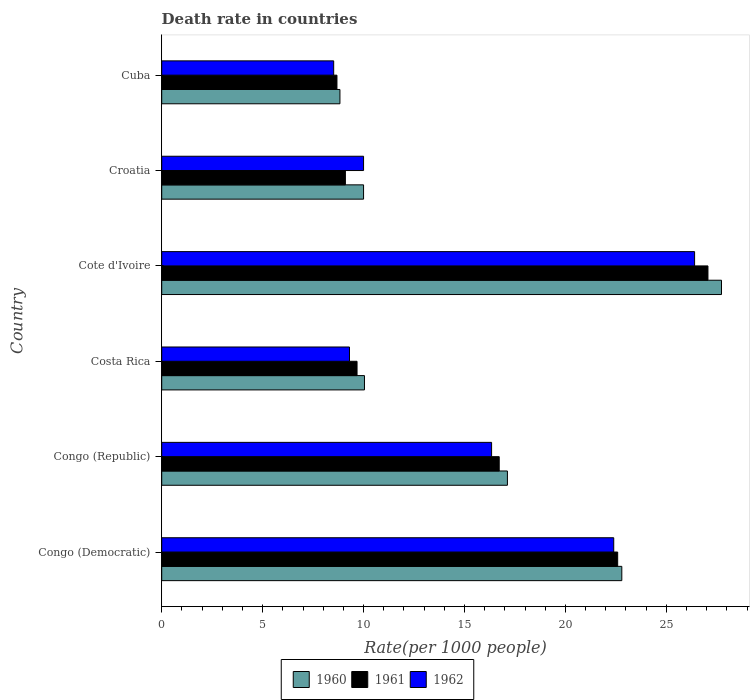How many groups of bars are there?
Offer a terse response. 6. Are the number of bars per tick equal to the number of legend labels?
Make the answer very short. Yes. Are the number of bars on each tick of the Y-axis equal?
Keep it short and to the point. Yes. How many bars are there on the 6th tick from the bottom?
Keep it short and to the point. 3. What is the label of the 2nd group of bars from the top?
Provide a short and direct response. Croatia. In how many cases, is the number of bars for a given country not equal to the number of legend labels?
Provide a succinct answer. 0. What is the death rate in 1960 in Congo (Republic)?
Offer a very short reply. 17.13. Across all countries, what is the maximum death rate in 1962?
Your answer should be very brief. 26.4. Across all countries, what is the minimum death rate in 1961?
Keep it short and to the point. 8.68. In which country was the death rate in 1960 maximum?
Make the answer very short. Cote d'Ivoire. In which country was the death rate in 1962 minimum?
Your answer should be very brief. Cuba. What is the total death rate in 1962 in the graph?
Ensure brevity in your answer.  92.96. What is the difference between the death rate in 1961 in Cote d'Ivoire and that in Croatia?
Give a very brief answer. 17.96. What is the difference between the death rate in 1961 in Cuba and the death rate in 1960 in Cote d'Ivoire?
Keep it short and to the point. -19.05. What is the average death rate in 1960 per country?
Your response must be concise. 16.09. What is the difference between the death rate in 1960 and death rate in 1962 in Cote d'Ivoire?
Provide a short and direct response. 1.33. In how many countries, is the death rate in 1961 greater than 23 ?
Your response must be concise. 1. What is the ratio of the death rate in 1962 in Congo (Democratic) to that in Congo (Republic)?
Keep it short and to the point. 1.37. Is the difference between the death rate in 1960 in Cote d'Ivoire and Cuba greater than the difference between the death rate in 1962 in Cote d'Ivoire and Cuba?
Offer a very short reply. Yes. What is the difference between the highest and the second highest death rate in 1960?
Make the answer very short. 4.94. What is the difference between the highest and the lowest death rate in 1962?
Ensure brevity in your answer.  17.88. In how many countries, is the death rate in 1961 greater than the average death rate in 1961 taken over all countries?
Provide a short and direct response. 3. Is the sum of the death rate in 1961 in Congo (Democratic) and Costa Rica greater than the maximum death rate in 1960 across all countries?
Offer a terse response. Yes. What does the 1st bar from the top in Cote d'Ivoire represents?
Your answer should be very brief. 1962. What does the 1st bar from the bottom in Congo (Republic) represents?
Provide a succinct answer. 1960. How many bars are there?
Give a very brief answer. 18. How many countries are there in the graph?
Offer a very short reply. 6. What is the difference between two consecutive major ticks on the X-axis?
Give a very brief answer. 5. Does the graph contain any zero values?
Offer a very short reply. No. Does the graph contain grids?
Your answer should be very brief. No. Where does the legend appear in the graph?
Provide a short and direct response. Bottom center. What is the title of the graph?
Offer a terse response. Death rate in countries. What is the label or title of the X-axis?
Make the answer very short. Rate(per 1000 people). What is the label or title of the Y-axis?
Keep it short and to the point. Country. What is the Rate(per 1000 people) of 1960 in Congo (Democratic)?
Provide a short and direct response. 22.79. What is the Rate(per 1000 people) of 1961 in Congo (Democratic)?
Your answer should be compact. 22.59. What is the Rate(per 1000 people) of 1962 in Congo (Democratic)?
Provide a short and direct response. 22.39. What is the Rate(per 1000 people) in 1960 in Congo (Republic)?
Keep it short and to the point. 17.13. What is the Rate(per 1000 people) in 1961 in Congo (Republic)?
Offer a very short reply. 16.72. What is the Rate(per 1000 people) in 1962 in Congo (Republic)?
Give a very brief answer. 16.34. What is the Rate(per 1000 people) in 1960 in Costa Rica?
Make the answer very short. 10.04. What is the Rate(per 1000 people) of 1961 in Costa Rica?
Provide a short and direct response. 9.68. What is the Rate(per 1000 people) of 1962 in Costa Rica?
Keep it short and to the point. 9.3. What is the Rate(per 1000 people) in 1960 in Cote d'Ivoire?
Offer a very short reply. 27.73. What is the Rate(per 1000 people) of 1961 in Cote d'Ivoire?
Your response must be concise. 27.06. What is the Rate(per 1000 people) in 1962 in Cote d'Ivoire?
Offer a terse response. 26.4. What is the Rate(per 1000 people) in 1960 in Croatia?
Provide a short and direct response. 10. What is the Rate(per 1000 people) in 1962 in Croatia?
Offer a terse response. 10. What is the Rate(per 1000 people) of 1960 in Cuba?
Keep it short and to the point. 8.83. What is the Rate(per 1000 people) of 1961 in Cuba?
Make the answer very short. 8.68. What is the Rate(per 1000 people) of 1962 in Cuba?
Keep it short and to the point. 8.52. Across all countries, what is the maximum Rate(per 1000 people) of 1960?
Provide a short and direct response. 27.73. Across all countries, what is the maximum Rate(per 1000 people) of 1961?
Give a very brief answer. 27.06. Across all countries, what is the maximum Rate(per 1000 people) of 1962?
Your answer should be compact. 26.4. Across all countries, what is the minimum Rate(per 1000 people) of 1960?
Offer a terse response. 8.83. Across all countries, what is the minimum Rate(per 1000 people) of 1961?
Ensure brevity in your answer.  8.68. Across all countries, what is the minimum Rate(per 1000 people) of 1962?
Ensure brevity in your answer.  8.52. What is the total Rate(per 1000 people) of 1960 in the graph?
Your answer should be compact. 96.53. What is the total Rate(per 1000 people) of 1961 in the graph?
Keep it short and to the point. 93.83. What is the total Rate(per 1000 people) of 1962 in the graph?
Your response must be concise. 92.96. What is the difference between the Rate(per 1000 people) of 1960 in Congo (Democratic) and that in Congo (Republic)?
Provide a short and direct response. 5.67. What is the difference between the Rate(per 1000 people) in 1961 in Congo (Democratic) and that in Congo (Republic)?
Your answer should be very brief. 5.87. What is the difference between the Rate(per 1000 people) in 1962 in Congo (Democratic) and that in Congo (Republic)?
Keep it short and to the point. 6.05. What is the difference between the Rate(per 1000 people) of 1960 in Congo (Democratic) and that in Costa Rica?
Provide a short and direct response. 12.75. What is the difference between the Rate(per 1000 people) of 1961 in Congo (Democratic) and that in Costa Rica?
Offer a very short reply. 12.91. What is the difference between the Rate(per 1000 people) in 1962 in Congo (Democratic) and that in Costa Rica?
Your response must be concise. 13.09. What is the difference between the Rate(per 1000 people) in 1960 in Congo (Democratic) and that in Cote d'Ivoire?
Your response must be concise. -4.94. What is the difference between the Rate(per 1000 people) in 1961 in Congo (Democratic) and that in Cote d'Ivoire?
Your answer should be compact. -4.47. What is the difference between the Rate(per 1000 people) in 1962 in Congo (Democratic) and that in Cote d'Ivoire?
Your response must be concise. -4.01. What is the difference between the Rate(per 1000 people) in 1960 in Congo (Democratic) and that in Croatia?
Your answer should be very brief. 12.79. What is the difference between the Rate(per 1000 people) in 1961 in Congo (Democratic) and that in Croatia?
Provide a short and direct response. 13.49. What is the difference between the Rate(per 1000 people) in 1962 in Congo (Democratic) and that in Croatia?
Offer a terse response. 12.39. What is the difference between the Rate(per 1000 people) in 1960 in Congo (Democratic) and that in Cuba?
Your response must be concise. 13.96. What is the difference between the Rate(per 1000 people) of 1961 in Congo (Democratic) and that in Cuba?
Keep it short and to the point. 13.91. What is the difference between the Rate(per 1000 people) of 1962 in Congo (Democratic) and that in Cuba?
Offer a terse response. 13.87. What is the difference between the Rate(per 1000 people) of 1960 in Congo (Republic) and that in Costa Rica?
Your answer should be compact. 7.08. What is the difference between the Rate(per 1000 people) in 1961 in Congo (Republic) and that in Costa Rica?
Give a very brief answer. 7.04. What is the difference between the Rate(per 1000 people) of 1962 in Congo (Republic) and that in Costa Rica?
Your response must be concise. 7.04. What is the difference between the Rate(per 1000 people) of 1960 in Congo (Republic) and that in Cote d'Ivoire?
Your response must be concise. -10.61. What is the difference between the Rate(per 1000 people) of 1961 in Congo (Republic) and that in Cote d'Ivoire?
Make the answer very short. -10.34. What is the difference between the Rate(per 1000 people) in 1962 in Congo (Republic) and that in Cote d'Ivoire?
Offer a very short reply. -10.06. What is the difference between the Rate(per 1000 people) in 1960 in Congo (Republic) and that in Croatia?
Offer a very short reply. 7.13. What is the difference between the Rate(per 1000 people) in 1961 in Congo (Republic) and that in Croatia?
Your answer should be very brief. 7.62. What is the difference between the Rate(per 1000 people) in 1962 in Congo (Republic) and that in Croatia?
Ensure brevity in your answer.  6.34. What is the difference between the Rate(per 1000 people) in 1960 in Congo (Republic) and that in Cuba?
Your response must be concise. 8.3. What is the difference between the Rate(per 1000 people) of 1961 in Congo (Republic) and that in Cuba?
Give a very brief answer. 8.04. What is the difference between the Rate(per 1000 people) of 1962 in Congo (Republic) and that in Cuba?
Give a very brief answer. 7.82. What is the difference between the Rate(per 1000 people) in 1960 in Costa Rica and that in Cote d'Ivoire?
Your answer should be compact. -17.69. What is the difference between the Rate(per 1000 people) of 1961 in Costa Rica and that in Cote d'Ivoire?
Make the answer very short. -17.39. What is the difference between the Rate(per 1000 people) of 1962 in Costa Rica and that in Cote d'Ivoire?
Your response must be concise. -17.1. What is the difference between the Rate(per 1000 people) in 1960 in Costa Rica and that in Croatia?
Give a very brief answer. 0.04. What is the difference between the Rate(per 1000 people) in 1961 in Costa Rica and that in Croatia?
Provide a succinct answer. 0.58. What is the difference between the Rate(per 1000 people) in 1962 in Costa Rica and that in Croatia?
Keep it short and to the point. -0.7. What is the difference between the Rate(per 1000 people) in 1960 in Costa Rica and that in Cuba?
Provide a succinct answer. 1.22. What is the difference between the Rate(per 1000 people) in 1961 in Costa Rica and that in Cuba?
Make the answer very short. 0.99. What is the difference between the Rate(per 1000 people) in 1962 in Costa Rica and that in Cuba?
Your answer should be very brief. 0.78. What is the difference between the Rate(per 1000 people) in 1960 in Cote d'Ivoire and that in Croatia?
Your response must be concise. 17.73. What is the difference between the Rate(per 1000 people) of 1961 in Cote d'Ivoire and that in Croatia?
Your response must be concise. 17.96. What is the difference between the Rate(per 1000 people) of 1962 in Cote d'Ivoire and that in Croatia?
Your answer should be very brief. 16.4. What is the difference between the Rate(per 1000 people) of 1960 in Cote d'Ivoire and that in Cuba?
Ensure brevity in your answer.  18.9. What is the difference between the Rate(per 1000 people) in 1961 in Cote d'Ivoire and that in Cuba?
Your answer should be very brief. 18.38. What is the difference between the Rate(per 1000 people) in 1962 in Cote d'Ivoire and that in Cuba?
Make the answer very short. 17.88. What is the difference between the Rate(per 1000 people) of 1960 in Croatia and that in Cuba?
Ensure brevity in your answer.  1.17. What is the difference between the Rate(per 1000 people) in 1961 in Croatia and that in Cuba?
Offer a terse response. 0.42. What is the difference between the Rate(per 1000 people) of 1962 in Croatia and that in Cuba?
Your response must be concise. 1.48. What is the difference between the Rate(per 1000 people) in 1960 in Congo (Democratic) and the Rate(per 1000 people) in 1961 in Congo (Republic)?
Your answer should be compact. 6.07. What is the difference between the Rate(per 1000 people) in 1960 in Congo (Democratic) and the Rate(per 1000 people) in 1962 in Congo (Republic)?
Make the answer very short. 6.45. What is the difference between the Rate(per 1000 people) of 1961 in Congo (Democratic) and the Rate(per 1000 people) of 1962 in Congo (Republic)?
Your response must be concise. 6.25. What is the difference between the Rate(per 1000 people) in 1960 in Congo (Democratic) and the Rate(per 1000 people) in 1961 in Costa Rica?
Make the answer very short. 13.12. What is the difference between the Rate(per 1000 people) of 1960 in Congo (Democratic) and the Rate(per 1000 people) of 1962 in Costa Rica?
Provide a succinct answer. 13.49. What is the difference between the Rate(per 1000 people) in 1961 in Congo (Democratic) and the Rate(per 1000 people) in 1962 in Costa Rica?
Provide a succinct answer. 13.29. What is the difference between the Rate(per 1000 people) in 1960 in Congo (Democratic) and the Rate(per 1000 people) in 1961 in Cote d'Ivoire?
Ensure brevity in your answer.  -4.27. What is the difference between the Rate(per 1000 people) of 1960 in Congo (Democratic) and the Rate(per 1000 people) of 1962 in Cote d'Ivoire?
Keep it short and to the point. -3.61. What is the difference between the Rate(per 1000 people) in 1961 in Congo (Democratic) and the Rate(per 1000 people) in 1962 in Cote d'Ivoire?
Give a very brief answer. -3.81. What is the difference between the Rate(per 1000 people) of 1960 in Congo (Democratic) and the Rate(per 1000 people) of 1961 in Croatia?
Provide a short and direct response. 13.69. What is the difference between the Rate(per 1000 people) in 1960 in Congo (Democratic) and the Rate(per 1000 people) in 1962 in Croatia?
Offer a very short reply. 12.79. What is the difference between the Rate(per 1000 people) of 1961 in Congo (Democratic) and the Rate(per 1000 people) of 1962 in Croatia?
Provide a succinct answer. 12.59. What is the difference between the Rate(per 1000 people) in 1960 in Congo (Democratic) and the Rate(per 1000 people) in 1961 in Cuba?
Keep it short and to the point. 14.11. What is the difference between the Rate(per 1000 people) of 1960 in Congo (Democratic) and the Rate(per 1000 people) of 1962 in Cuba?
Keep it short and to the point. 14.27. What is the difference between the Rate(per 1000 people) of 1961 in Congo (Democratic) and the Rate(per 1000 people) of 1962 in Cuba?
Your response must be concise. 14.07. What is the difference between the Rate(per 1000 people) in 1960 in Congo (Republic) and the Rate(per 1000 people) in 1961 in Costa Rica?
Offer a terse response. 7.45. What is the difference between the Rate(per 1000 people) of 1960 in Congo (Republic) and the Rate(per 1000 people) of 1962 in Costa Rica?
Your answer should be compact. 7.82. What is the difference between the Rate(per 1000 people) in 1961 in Congo (Republic) and the Rate(per 1000 people) in 1962 in Costa Rica?
Keep it short and to the point. 7.42. What is the difference between the Rate(per 1000 people) in 1960 in Congo (Republic) and the Rate(per 1000 people) in 1961 in Cote d'Ivoire?
Your response must be concise. -9.94. What is the difference between the Rate(per 1000 people) of 1960 in Congo (Republic) and the Rate(per 1000 people) of 1962 in Cote d'Ivoire?
Your answer should be very brief. -9.27. What is the difference between the Rate(per 1000 people) in 1961 in Congo (Republic) and the Rate(per 1000 people) in 1962 in Cote d'Ivoire?
Make the answer very short. -9.68. What is the difference between the Rate(per 1000 people) of 1960 in Congo (Republic) and the Rate(per 1000 people) of 1961 in Croatia?
Your answer should be very brief. 8.03. What is the difference between the Rate(per 1000 people) in 1960 in Congo (Republic) and the Rate(per 1000 people) in 1962 in Croatia?
Provide a short and direct response. 7.13. What is the difference between the Rate(per 1000 people) in 1961 in Congo (Republic) and the Rate(per 1000 people) in 1962 in Croatia?
Ensure brevity in your answer.  6.72. What is the difference between the Rate(per 1000 people) in 1960 in Congo (Republic) and the Rate(per 1000 people) in 1961 in Cuba?
Offer a terse response. 8.45. What is the difference between the Rate(per 1000 people) of 1960 in Congo (Republic) and the Rate(per 1000 people) of 1962 in Cuba?
Offer a terse response. 8.61. What is the difference between the Rate(per 1000 people) of 1961 in Congo (Republic) and the Rate(per 1000 people) of 1962 in Cuba?
Provide a short and direct response. 8.2. What is the difference between the Rate(per 1000 people) of 1960 in Costa Rica and the Rate(per 1000 people) of 1961 in Cote d'Ivoire?
Your response must be concise. -17.02. What is the difference between the Rate(per 1000 people) in 1960 in Costa Rica and the Rate(per 1000 people) in 1962 in Cote d'Ivoire?
Offer a very short reply. -16.36. What is the difference between the Rate(per 1000 people) of 1961 in Costa Rica and the Rate(per 1000 people) of 1962 in Cote d'Ivoire?
Offer a very short reply. -16.72. What is the difference between the Rate(per 1000 people) of 1960 in Costa Rica and the Rate(per 1000 people) of 1961 in Croatia?
Keep it short and to the point. 0.94. What is the difference between the Rate(per 1000 people) of 1960 in Costa Rica and the Rate(per 1000 people) of 1962 in Croatia?
Your answer should be very brief. 0.04. What is the difference between the Rate(per 1000 people) in 1961 in Costa Rica and the Rate(per 1000 people) in 1962 in Croatia?
Your answer should be very brief. -0.32. What is the difference between the Rate(per 1000 people) in 1960 in Costa Rica and the Rate(per 1000 people) in 1961 in Cuba?
Offer a terse response. 1.36. What is the difference between the Rate(per 1000 people) of 1960 in Costa Rica and the Rate(per 1000 people) of 1962 in Cuba?
Ensure brevity in your answer.  1.52. What is the difference between the Rate(per 1000 people) in 1961 in Costa Rica and the Rate(per 1000 people) in 1962 in Cuba?
Offer a very short reply. 1.16. What is the difference between the Rate(per 1000 people) in 1960 in Cote d'Ivoire and the Rate(per 1000 people) in 1961 in Croatia?
Keep it short and to the point. 18.63. What is the difference between the Rate(per 1000 people) of 1960 in Cote d'Ivoire and the Rate(per 1000 people) of 1962 in Croatia?
Provide a succinct answer. 17.73. What is the difference between the Rate(per 1000 people) of 1961 in Cote d'Ivoire and the Rate(per 1000 people) of 1962 in Croatia?
Give a very brief answer. 17.06. What is the difference between the Rate(per 1000 people) in 1960 in Cote d'Ivoire and the Rate(per 1000 people) in 1961 in Cuba?
Keep it short and to the point. 19.05. What is the difference between the Rate(per 1000 people) in 1960 in Cote d'Ivoire and the Rate(per 1000 people) in 1962 in Cuba?
Your answer should be very brief. 19.21. What is the difference between the Rate(per 1000 people) of 1961 in Cote d'Ivoire and the Rate(per 1000 people) of 1962 in Cuba?
Ensure brevity in your answer.  18.54. What is the difference between the Rate(per 1000 people) of 1960 in Croatia and the Rate(per 1000 people) of 1961 in Cuba?
Provide a short and direct response. 1.32. What is the difference between the Rate(per 1000 people) of 1960 in Croatia and the Rate(per 1000 people) of 1962 in Cuba?
Ensure brevity in your answer.  1.48. What is the difference between the Rate(per 1000 people) in 1961 in Croatia and the Rate(per 1000 people) in 1962 in Cuba?
Keep it short and to the point. 0.58. What is the average Rate(per 1000 people) of 1960 per country?
Provide a succinct answer. 16.09. What is the average Rate(per 1000 people) of 1961 per country?
Provide a short and direct response. 15.64. What is the average Rate(per 1000 people) in 1962 per country?
Your answer should be compact. 15.49. What is the difference between the Rate(per 1000 people) in 1960 and Rate(per 1000 people) in 1961 in Congo (Democratic)?
Your response must be concise. 0.2. What is the difference between the Rate(per 1000 people) in 1960 and Rate(per 1000 people) in 1962 in Congo (Democratic)?
Offer a terse response. 0.4. What is the difference between the Rate(per 1000 people) of 1961 and Rate(per 1000 people) of 1962 in Congo (Democratic)?
Provide a short and direct response. 0.2. What is the difference between the Rate(per 1000 people) of 1960 and Rate(per 1000 people) of 1961 in Congo (Republic)?
Offer a terse response. 0.41. What is the difference between the Rate(per 1000 people) of 1960 and Rate(per 1000 people) of 1962 in Congo (Republic)?
Your response must be concise. 0.78. What is the difference between the Rate(per 1000 people) in 1961 and Rate(per 1000 people) in 1962 in Congo (Republic)?
Your answer should be very brief. 0.38. What is the difference between the Rate(per 1000 people) in 1960 and Rate(per 1000 people) in 1961 in Costa Rica?
Provide a succinct answer. 0.37. What is the difference between the Rate(per 1000 people) of 1960 and Rate(per 1000 people) of 1962 in Costa Rica?
Offer a terse response. 0.74. What is the difference between the Rate(per 1000 people) in 1961 and Rate(per 1000 people) in 1962 in Costa Rica?
Your answer should be compact. 0.37. What is the difference between the Rate(per 1000 people) of 1960 and Rate(per 1000 people) of 1961 in Cote d'Ivoire?
Offer a terse response. 0.67. What is the difference between the Rate(per 1000 people) in 1960 and Rate(per 1000 people) in 1962 in Cote d'Ivoire?
Your answer should be very brief. 1.33. What is the difference between the Rate(per 1000 people) of 1961 and Rate(per 1000 people) of 1962 in Cote d'Ivoire?
Your answer should be compact. 0.66. What is the difference between the Rate(per 1000 people) in 1960 and Rate(per 1000 people) in 1961 in Cuba?
Your answer should be compact. 0.15. What is the difference between the Rate(per 1000 people) of 1960 and Rate(per 1000 people) of 1962 in Cuba?
Provide a succinct answer. 0.31. What is the difference between the Rate(per 1000 people) of 1961 and Rate(per 1000 people) of 1962 in Cuba?
Make the answer very short. 0.16. What is the ratio of the Rate(per 1000 people) of 1960 in Congo (Democratic) to that in Congo (Republic)?
Offer a terse response. 1.33. What is the ratio of the Rate(per 1000 people) in 1961 in Congo (Democratic) to that in Congo (Republic)?
Ensure brevity in your answer.  1.35. What is the ratio of the Rate(per 1000 people) in 1962 in Congo (Democratic) to that in Congo (Republic)?
Offer a terse response. 1.37. What is the ratio of the Rate(per 1000 people) of 1960 in Congo (Democratic) to that in Costa Rica?
Keep it short and to the point. 2.27. What is the ratio of the Rate(per 1000 people) in 1961 in Congo (Democratic) to that in Costa Rica?
Your answer should be very brief. 2.33. What is the ratio of the Rate(per 1000 people) of 1962 in Congo (Democratic) to that in Costa Rica?
Make the answer very short. 2.41. What is the ratio of the Rate(per 1000 people) of 1960 in Congo (Democratic) to that in Cote d'Ivoire?
Offer a very short reply. 0.82. What is the ratio of the Rate(per 1000 people) of 1961 in Congo (Democratic) to that in Cote d'Ivoire?
Keep it short and to the point. 0.83. What is the ratio of the Rate(per 1000 people) in 1962 in Congo (Democratic) to that in Cote d'Ivoire?
Your answer should be very brief. 0.85. What is the ratio of the Rate(per 1000 people) of 1960 in Congo (Democratic) to that in Croatia?
Provide a short and direct response. 2.28. What is the ratio of the Rate(per 1000 people) in 1961 in Congo (Democratic) to that in Croatia?
Make the answer very short. 2.48. What is the ratio of the Rate(per 1000 people) of 1962 in Congo (Democratic) to that in Croatia?
Make the answer very short. 2.24. What is the ratio of the Rate(per 1000 people) of 1960 in Congo (Democratic) to that in Cuba?
Your response must be concise. 2.58. What is the ratio of the Rate(per 1000 people) of 1961 in Congo (Democratic) to that in Cuba?
Make the answer very short. 2.6. What is the ratio of the Rate(per 1000 people) in 1962 in Congo (Democratic) to that in Cuba?
Provide a short and direct response. 2.63. What is the ratio of the Rate(per 1000 people) of 1960 in Congo (Republic) to that in Costa Rica?
Ensure brevity in your answer.  1.71. What is the ratio of the Rate(per 1000 people) in 1961 in Congo (Republic) to that in Costa Rica?
Provide a short and direct response. 1.73. What is the ratio of the Rate(per 1000 people) in 1962 in Congo (Republic) to that in Costa Rica?
Your answer should be compact. 1.76. What is the ratio of the Rate(per 1000 people) of 1960 in Congo (Republic) to that in Cote d'Ivoire?
Provide a succinct answer. 0.62. What is the ratio of the Rate(per 1000 people) in 1961 in Congo (Republic) to that in Cote d'Ivoire?
Provide a succinct answer. 0.62. What is the ratio of the Rate(per 1000 people) in 1962 in Congo (Republic) to that in Cote d'Ivoire?
Provide a short and direct response. 0.62. What is the ratio of the Rate(per 1000 people) of 1960 in Congo (Republic) to that in Croatia?
Ensure brevity in your answer.  1.71. What is the ratio of the Rate(per 1000 people) of 1961 in Congo (Republic) to that in Croatia?
Offer a very short reply. 1.84. What is the ratio of the Rate(per 1000 people) in 1962 in Congo (Republic) to that in Croatia?
Keep it short and to the point. 1.63. What is the ratio of the Rate(per 1000 people) in 1960 in Congo (Republic) to that in Cuba?
Ensure brevity in your answer.  1.94. What is the ratio of the Rate(per 1000 people) in 1961 in Congo (Republic) to that in Cuba?
Your answer should be very brief. 1.93. What is the ratio of the Rate(per 1000 people) of 1962 in Congo (Republic) to that in Cuba?
Keep it short and to the point. 1.92. What is the ratio of the Rate(per 1000 people) of 1960 in Costa Rica to that in Cote d'Ivoire?
Ensure brevity in your answer.  0.36. What is the ratio of the Rate(per 1000 people) of 1961 in Costa Rica to that in Cote d'Ivoire?
Give a very brief answer. 0.36. What is the ratio of the Rate(per 1000 people) of 1962 in Costa Rica to that in Cote d'Ivoire?
Keep it short and to the point. 0.35. What is the ratio of the Rate(per 1000 people) of 1961 in Costa Rica to that in Croatia?
Your response must be concise. 1.06. What is the ratio of the Rate(per 1000 people) of 1962 in Costa Rica to that in Croatia?
Your answer should be very brief. 0.93. What is the ratio of the Rate(per 1000 people) of 1960 in Costa Rica to that in Cuba?
Your answer should be compact. 1.14. What is the ratio of the Rate(per 1000 people) in 1961 in Costa Rica to that in Cuba?
Your answer should be very brief. 1.11. What is the ratio of the Rate(per 1000 people) in 1962 in Costa Rica to that in Cuba?
Offer a very short reply. 1.09. What is the ratio of the Rate(per 1000 people) in 1960 in Cote d'Ivoire to that in Croatia?
Keep it short and to the point. 2.77. What is the ratio of the Rate(per 1000 people) in 1961 in Cote d'Ivoire to that in Croatia?
Offer a terse response. 2.97. What is the ratio of the Rate(per 1000 people) of 1962 in Cote d'Ivoire to that in Croatia?
Provide a succinct answer. 2.64. What is the ratio of the Rate(per 1000 people) in 1960 in Cote d'Ivoire to that in Cuba?
Give a very brief answer. 3.14. What is the ratio of the Rate(per 1000 people) in 1961 in Cote d'Ivoire to that in Cuba?
Make the answer very short. 3.12. What is the ratio of the Rate(per 1000 people) in 1962 in Cote d'Ivoire to that in Cuba?
Provide a short and direct response. 3.1. What is the ratio of the Rate(per 1000 people) in 1960 in Croatia to that in Cuba?
Your response must be concise. 1.13. What is the ratio of the Rate(per 1000 people) in 1961 in Croatia to that in Cuba?
Offer a terse response. 1.05. What is the ratio of the Rate(per 1000 people) of 1962 in Croatia to that in Cuba?
Offer a terse response. 1.17. What is the difference between the highest and the second highest Rate(per 1000 people) of 1960?
Make the answer very short. 4.94. What is the difference between the highest and the second highest Rate(per 1000 people) of 1961?
Offer a very short reply. 4.47. What is the difference between the highest and the second highest Rate(per 1000 people) of 1962?
Your answer should be very brief. 4.01. What is the difference between the highest and the lowest Rate(per 1000 people) of 1960?
Your answer should be compact. 18.9. What is the difference between the highest and the lowest Rate(per 1000 people) of 1961?
Your answer should be very brief. 18.38. What is the difference between the highest and the lowest Rate(per 1000 people) of 1962?
Provide a succinct answer. 17.88. 